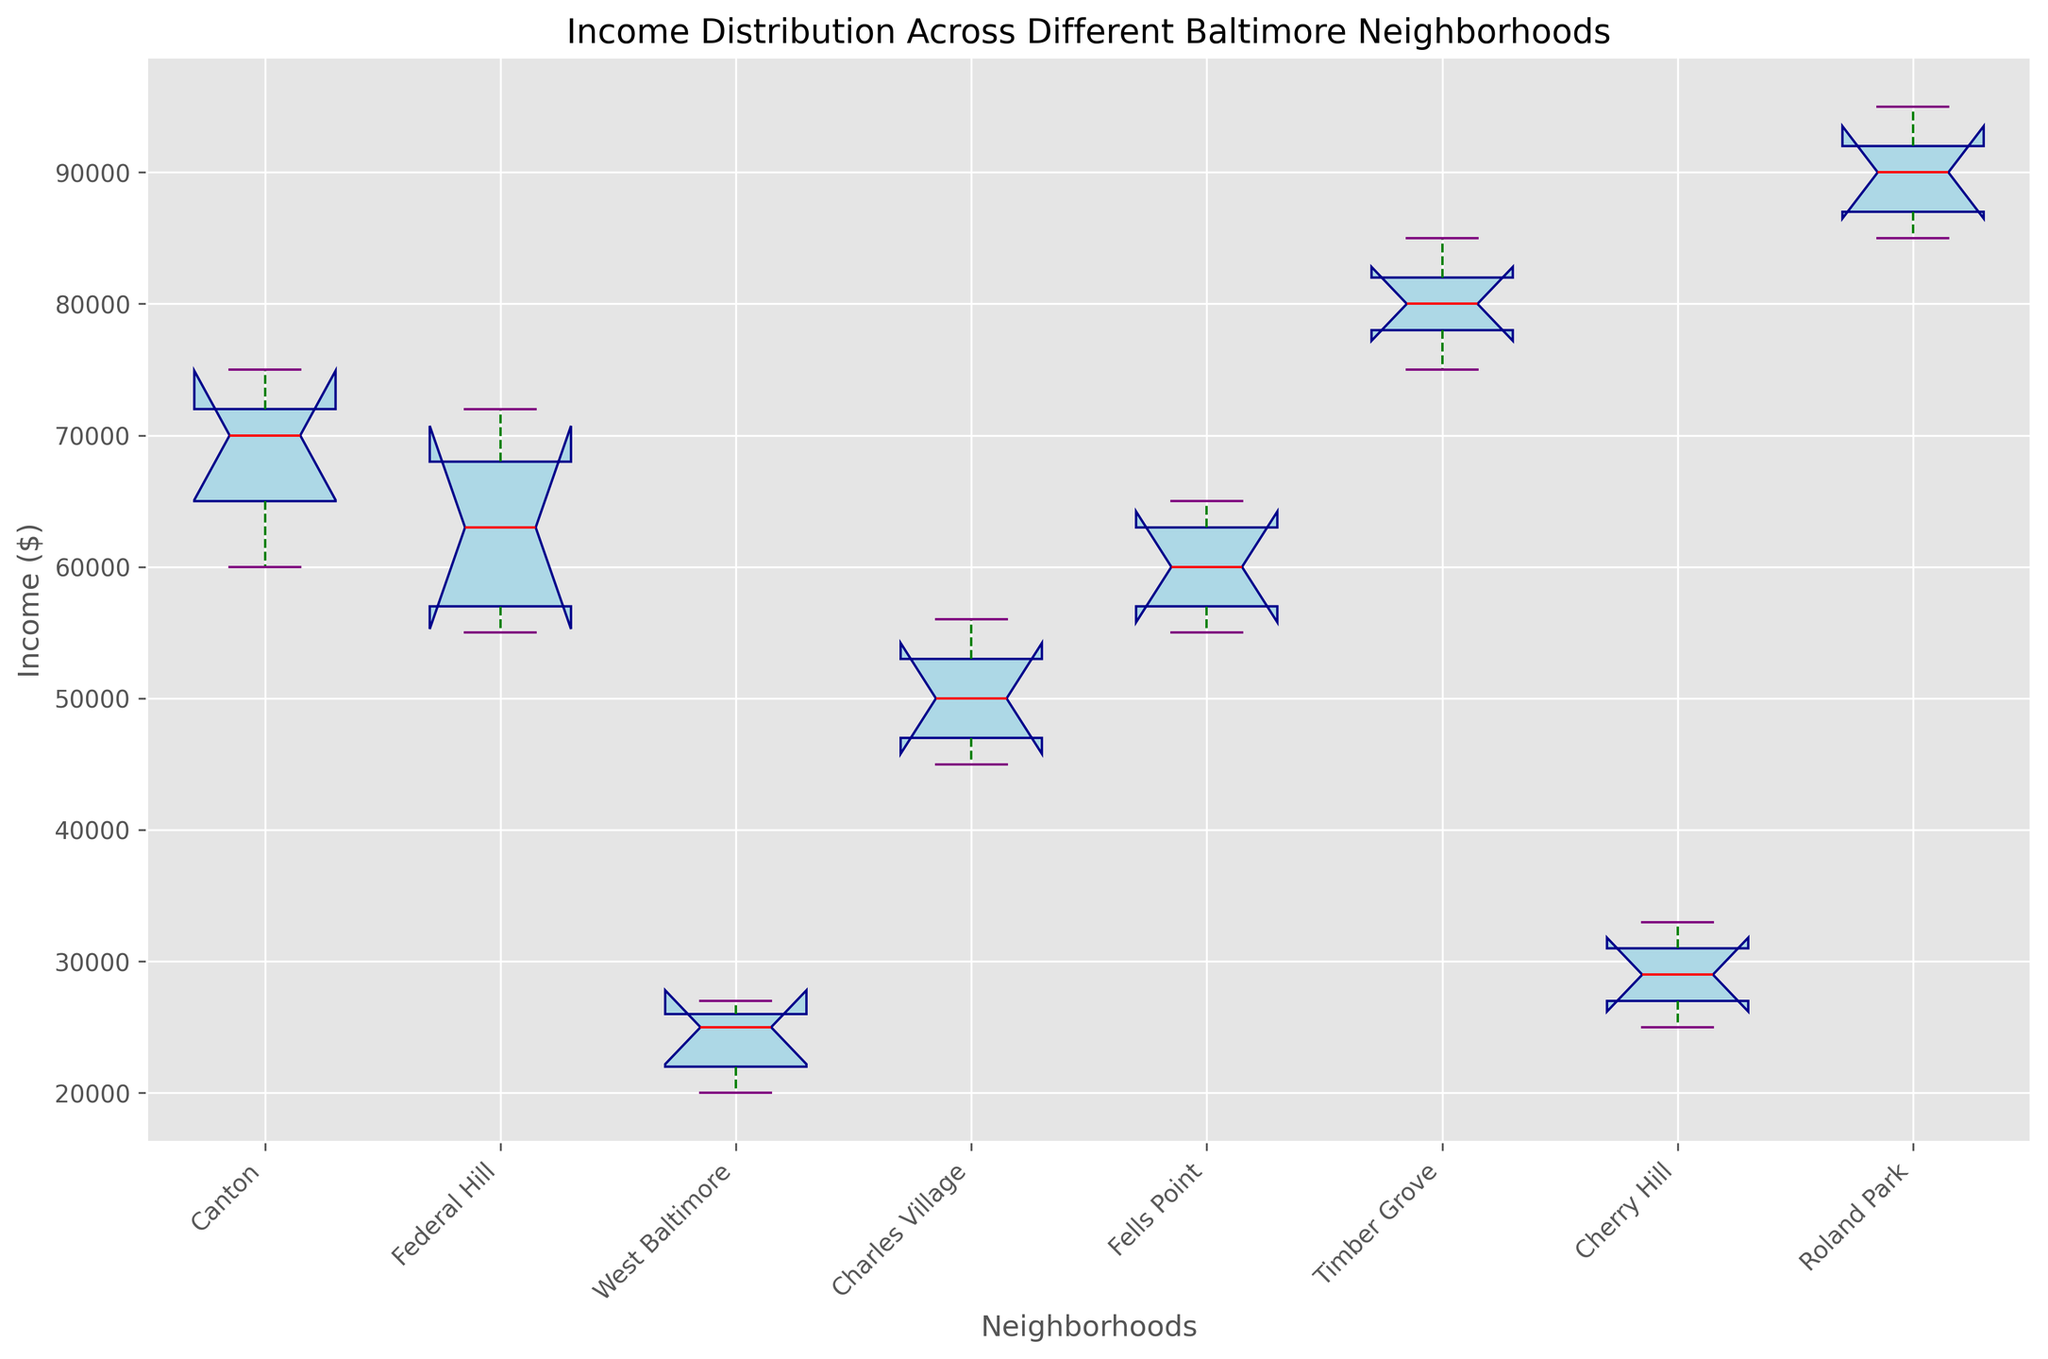Which neighborhood has the highest median income? The box plot shows the median income as the red line within each box. By comparing the position of the red lines, Roland Park has the highest median income as its median line is the highest among all neighborhoods.
Answer: Roland Park Which neighborhood displays the greatest range in income distribution? The range of income distribution can be identified by the span between the bottom and top whiskers of the box plots. West Baltimore shows the greatest range since its whiskers extend the furthest, indicating a wide spread in income.
Answer: West Baltimore How does the median income of Federal Hill compare to that of Fells Point? Federal Hill’s median income is represented by its red line, which is slightly lower than the median income of Fells Point. Therefore, Fells Point has a higher median income compared to Federal Hill.
Answer: Fells Point is higher Which neighborhoods have the lowest median income and what is this value approximately? The lowest median income is identified by the red line that is closest to the bottom of the plot. West Baltimore has the lowest median income, approximately around $25000.
Answer: West Baltimore, ~$25000 In which neighborhood is the interquartile range (IQR) the smallest? The IQR is the range between the bottom and top edges of the boxes. Roland Park shows the smallest IQR as its box is the most compressed, indicating a narrow spread of the middle 50% of incomes.
Answer: Roland Park What is the median income of Charles Village? By locating the red line within the Charles Village box plot, the median income is approximately identified as around $50000.
Answer: ~$50000 Comparing Canton and Cherry Hill, which neighborhood has a wider distribution of incomes? The distribution width is indicated by the span of the whiskers from bottom to top. Cherry Hill shows a wider distribution compared to Canton as its whiskers cover a larger vertical range.
Answer: Cherry Hill Which neighborhood's income 75th percentile is similar to Cherry Hill's maximum income? The 75th percentile is represented by the top edge of the box. Fells Point's 75th percentile is quite similar in value to the maximum income in Cherry Hill, both approximating around $65000.
Answer: Fells Point Which neighborhoods have outliers, and how do you identify them? Outliers can be identified by looking for individual points outside the whiskers. Timber Grove and Roland Park clearly display such points outside their whiskers, indicating income outliers.
Answer: Timber Grove, Roland Park 